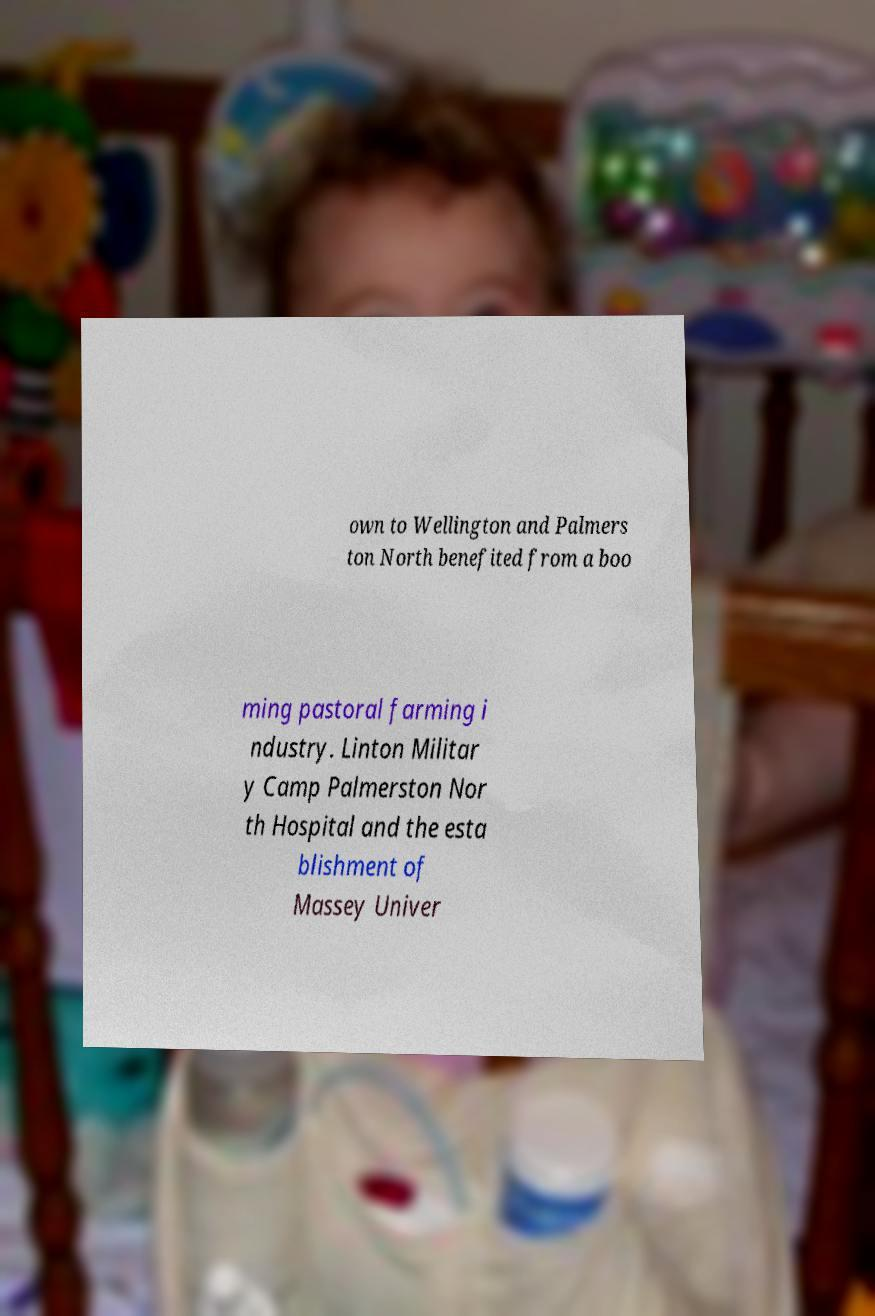Can you read and provide the text displayed in the image?This photo seems to have some interesting text. Can you extract and type it out for me? own to Wellington and Palmers ton North benefited from a boo ming pastoral farming i ndustry. Linton Militar y Camp Palmerston Nor th Hospital and the esta blishment of Massey Univer 